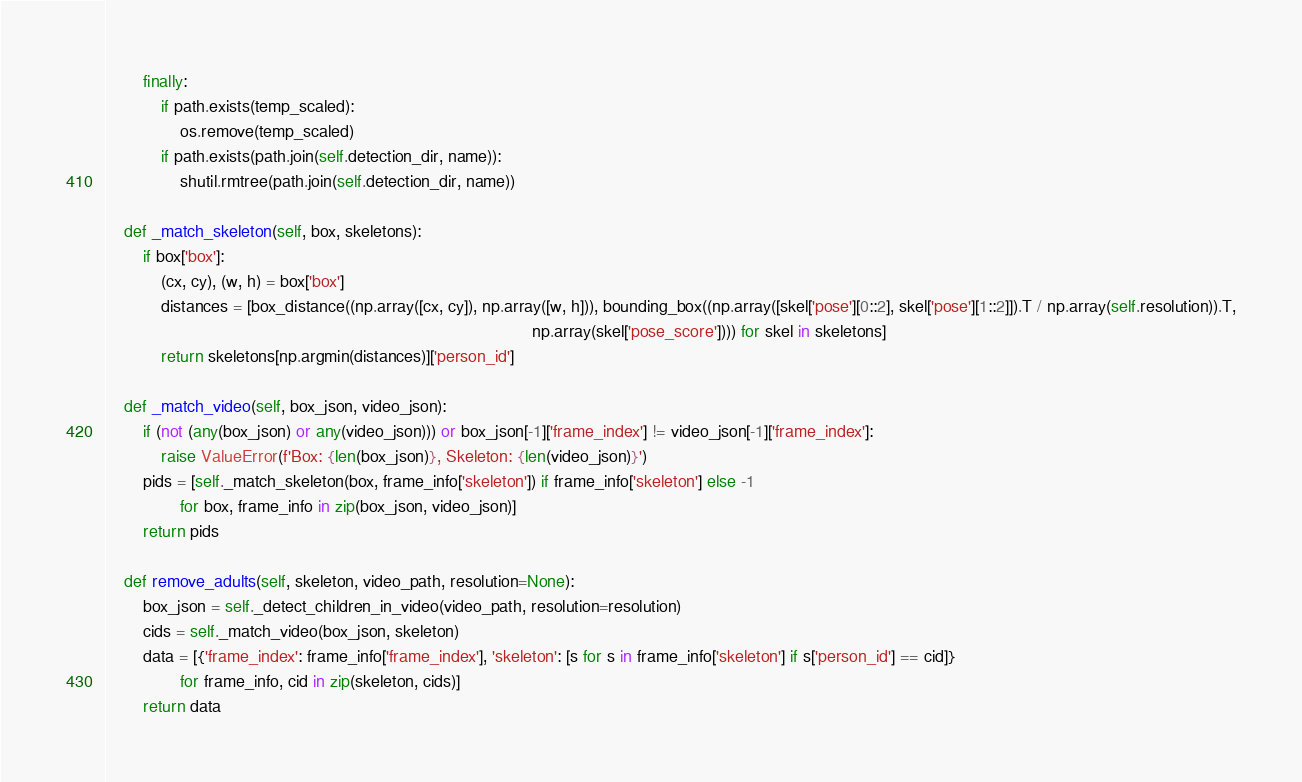Convert code to text. <code><loc_0><loc_0><loc_500><loc_500><_Python_>        finally:
            if path.exists(temp_scaled):
                os.remove(temp_scaled)
            if path.exists(path.join(self.detection_dir, name)):
                shutil.rmtree(path.join(self.detection_dir, name))

    def _match_skeleton(self, box, skeletons):
        if box['box']:
            (cx, cy), (w, h) = box['box']
            distances = [box_distance((np.array([cx, cy]), np.array([w, h])), bounding_box((np.array([skel['pose'][0::2], skel['pose'][1::2]]).T / np.array(self.resolution)).T,
                                                                                           np.array(skel['pose_score']))) for skel in skeletons]
            return skeletons[np.argmin(distances)]['person_id']

    def _match_video(self, box_json, video_json):
        if (not (any(box_json) or any(video_json))) or box_json[-1]['frame_index'] != video_json[-1]['frame_index']:
            raise ValueError(f'Box: {len(box_json)}, Skeleton: {len(video_json)}')
        pids = [self._match_skeleton(box, frame_info['skeleton']) if frame_info['skeleton'] else -1
                for box, frame_info in zip(box_json, video_json)]
        return pids

    def remove_adults(self, skeleton, video_path, resolution=None):
        box_json = self._detect_children_in_video(video_path, resolution=resolution)
        cids = self._match_video(box_json, skeleton)
        data = [{'frame_index': frame_info['frame_index'], 'skeleton': [s for s in frame_info['skeleton'] if s['person_id'] == cid]}
                for frame_info, cid in zip(skeleton, cids)]
        return data
</code> 